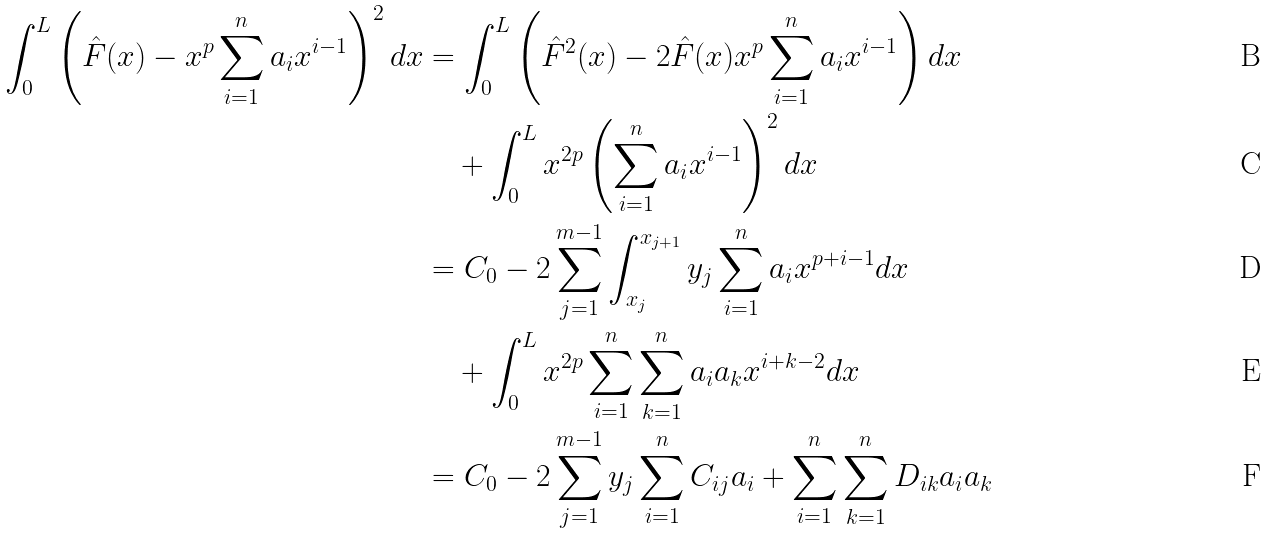<formula> <loc_0><loc_0><loc_500><loc_500>\int _ { 0 } ^ { L } \left ( \hat { F } ( x ) - x ^ { p } \sum _ { i = 1 } ^ { n } a _ { i } x ^ { i - 1 } \right ) ^ { 2 } d x & = \int _ { 0 } ^ { L } \left ( \hat { F } ^ { 2 } ( x ) - 2 \hat { F } ( x ) x ^ { p } \sum _ { i = 1 } ^ { n } a _ { i } x ^ { i - 1 } \right ) d x \\ & \quad + \int _ { 0 } ^ { L } x ^ { 2 p } \left ( \sum _ { i = 1 } ^ { n } a _ { i } x ^ { i - 1 } \right ) ^ { 2 } d x \\ & = C _ { 0 } - 2 \sum _ { j = 1 } ^ { m - 1 } \int _ { x _ { j } } ^ { x _ { j + 1 } } y _ { j } \sum _ { i = 1 } ^ { n } a _ { i } x ^ { p + i - 1 } d x \\ & \quad + \int _ { 0 } ^ { L } x ^ { 2 p } \sum _ { i = 1 } ^ { n } \sum _ { k = 1 } ^ { n } a _ { i } a _ { k } x ^ { i + k - 2 } d x \\ & = C _ { 0 } - 2 \sum _ { j = 1 } ^ { m - 1 } y _ { j } \sum _ { i = 1 } ^ { n } C _ { i j } a _ { i } + \sum _ { i = 1 } ^ { n } \sum _ { k = 1 } ^ { n } D _ { i k } a _ { i } a _ { k }</formula> 